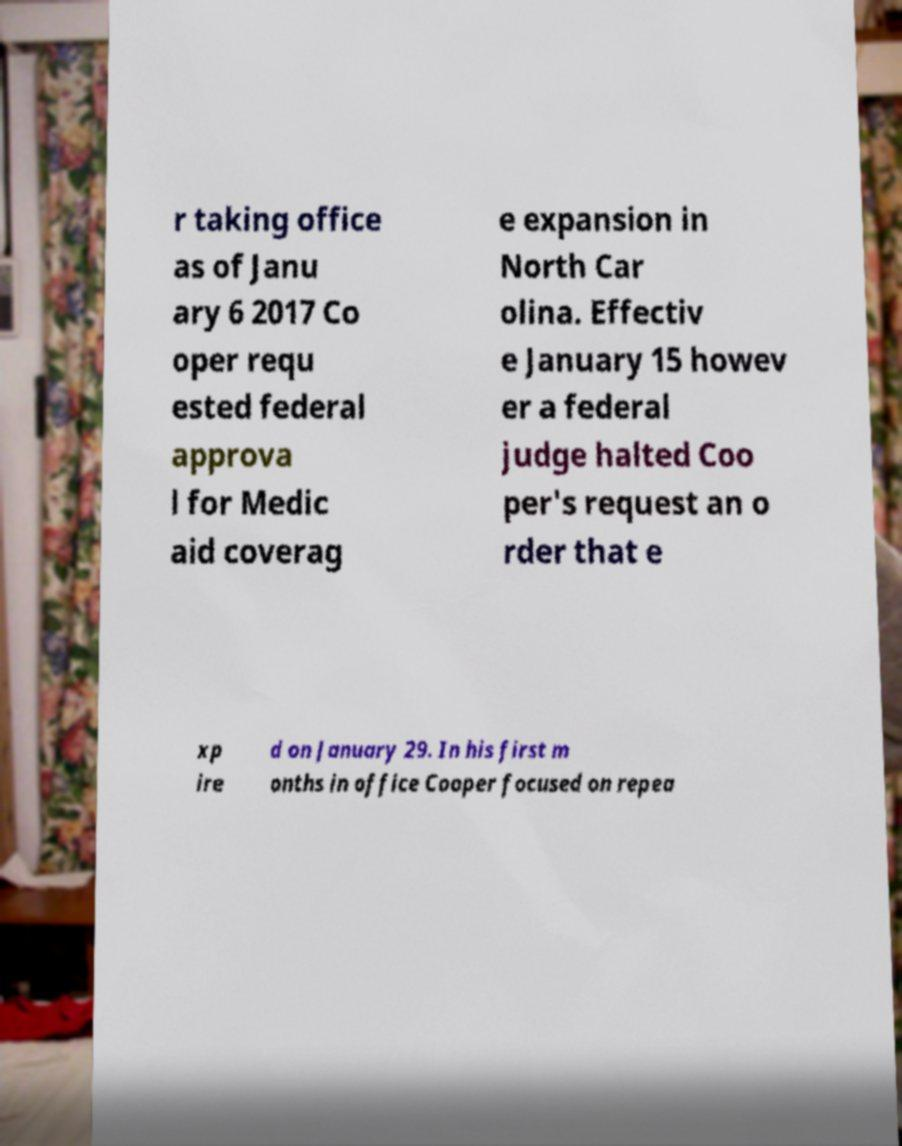Can you accurately transcribe the text from the provided image for me? r taking office as of Janu ary 6 2017 Co oper requ ested federal approva l for Medic aid coverag e expansion in North Car olina. Effectiv e January 15 howev er a federal judge halted Coo per's request an o rder that e xp ire d on January 29. In his first m onths in office Cooper focused on repea 